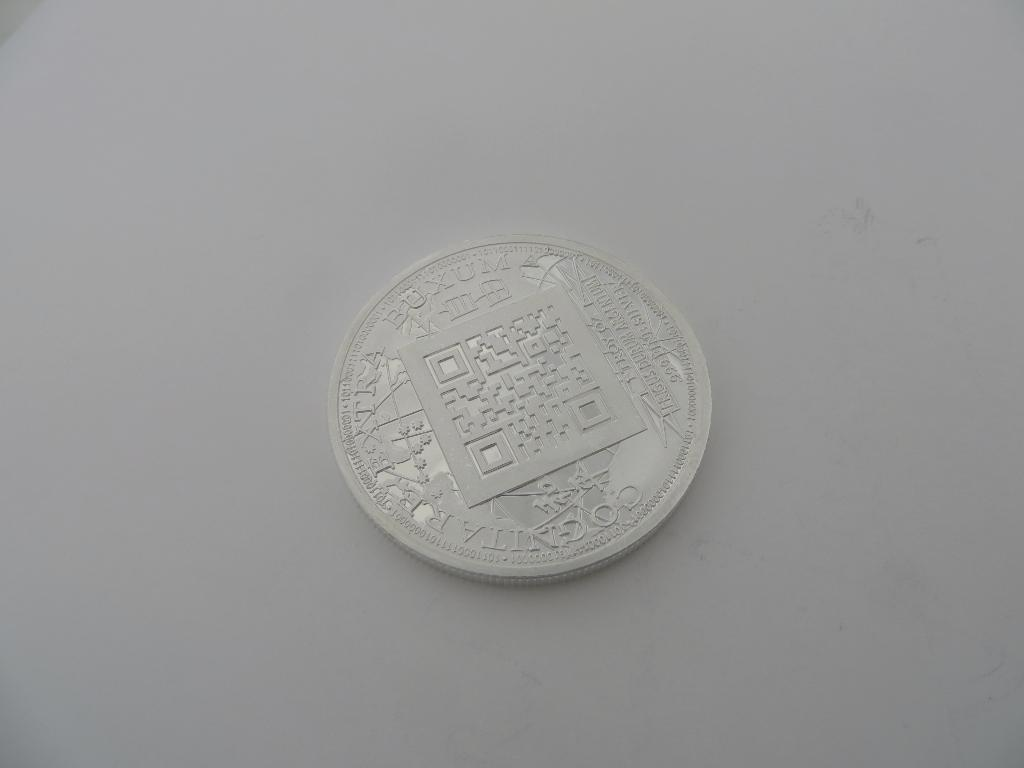<image>
Create a compact narrative representing the image presented. Silver coin on a table and the word BUXUM near the top. 